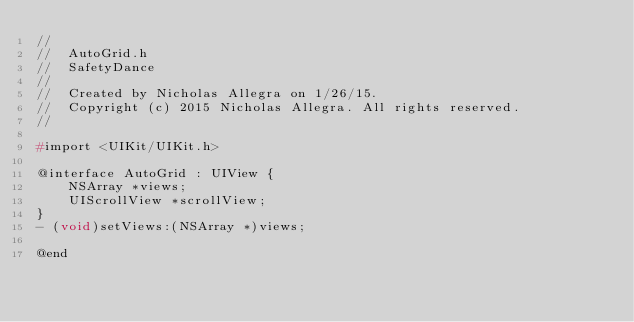<code> <loc_0><loc_0><loc_500><loc_500><_C_>//
//  AutoGrid.h
//  SafetyDance
//
//  Created by Nicholas Allegra on 1/26/15.
//  Copyright (c) 2015 Nicholas Allegra. All rights reserved.
//

#import <UIKit/UIKit.h>

@interface AutoGrid : UIView {
    NSArray *views;
    UIScrollView *scrollView;
}
- (void)setViews:(NSArray *)views;

@end
</code> 